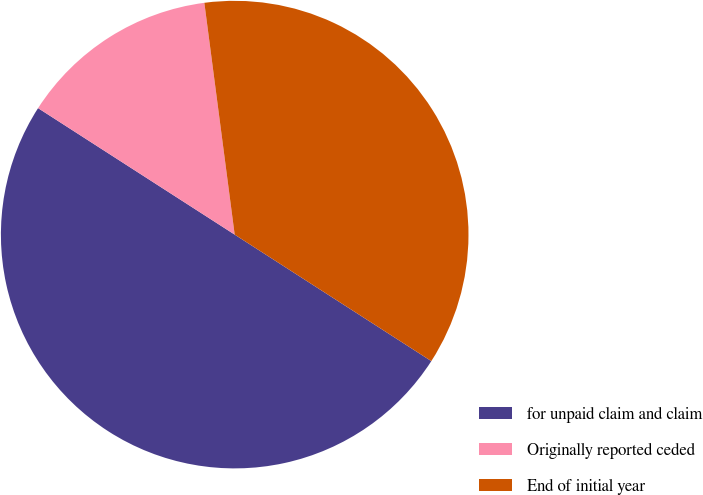Convert chart. <chart><loc_0><loc_0><loc_500><loc_500><pie_chart><fcel>for unpaid claim and claim<fcel>Originally reported ceded<fcel>End of initial year<nl><fcel>50.0%<fcel>13.83%<fcel>36.17%<nl></chart> 